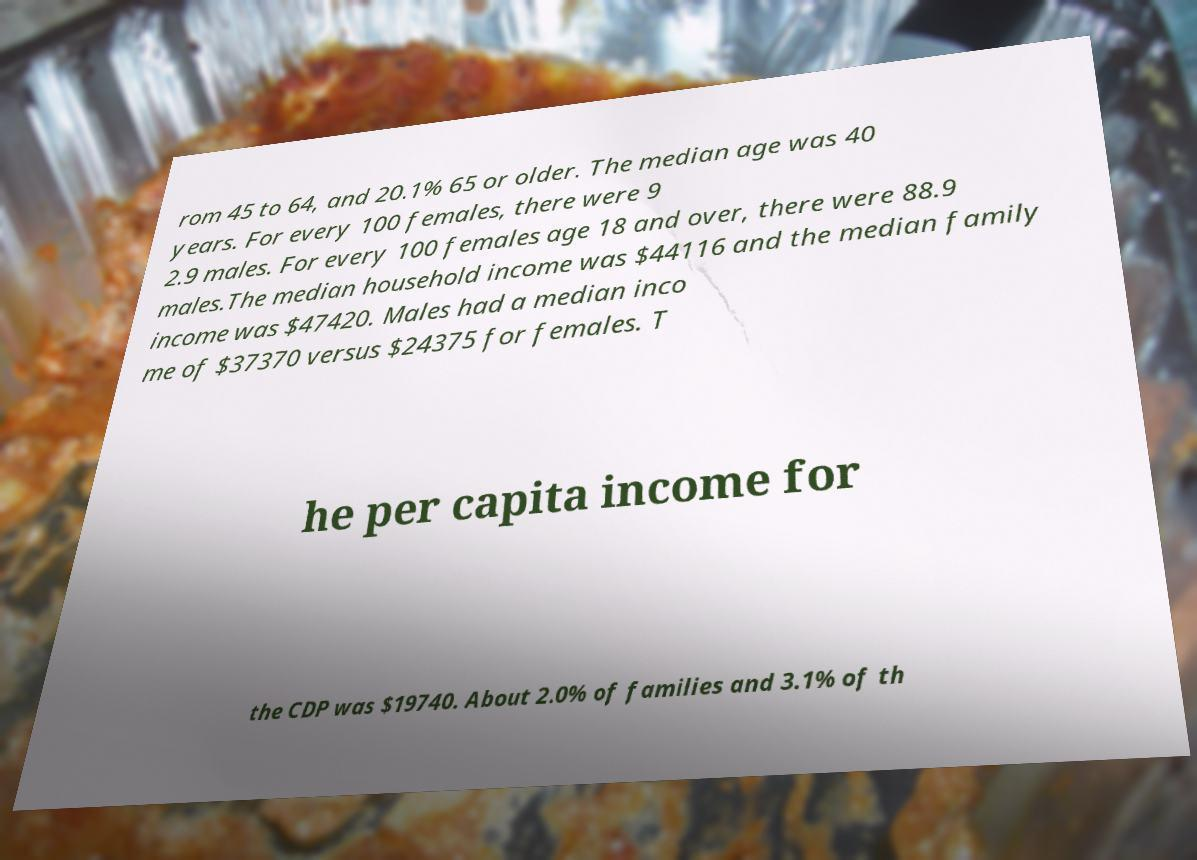For documentation purposes, I need the text within this image transcribed. Could you provide that? rom 45 to 64, and 20.1% 65 or older. The median age was 40 years. For every 100 females, there were 9 2.9 males. For every 100 females age 18 and over, there were 88.9 males.The median household income was $44116 and the median family income was $47420. Males had a median inco me of $37370 versus $24375 for females. T he per capita income for the CDP was $19740. About 2.0% of families and 3.1% of th 